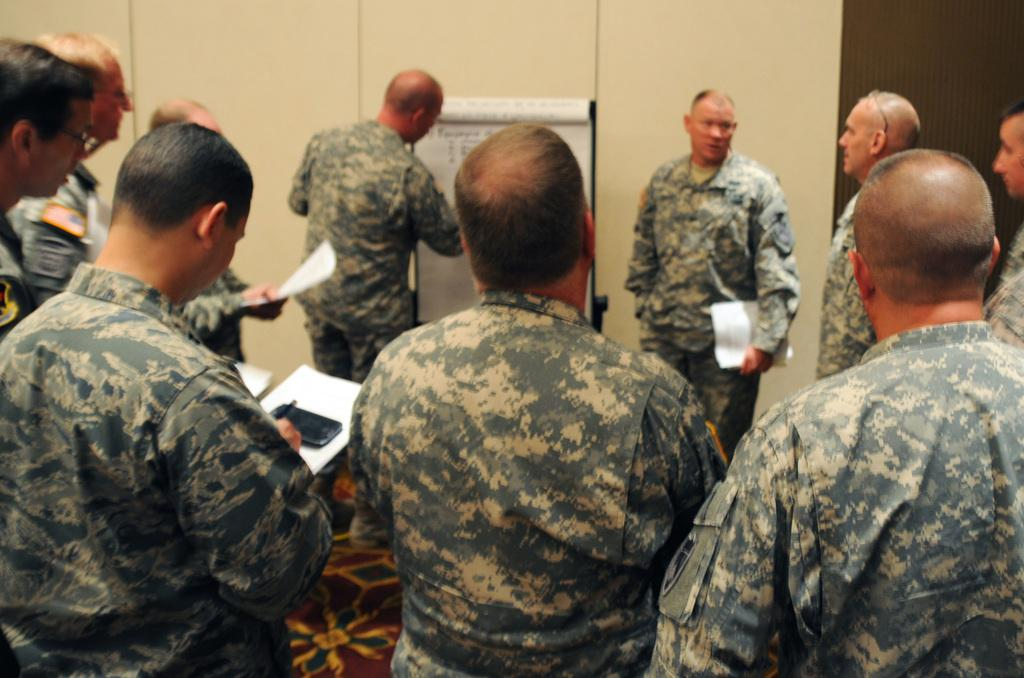What is happening in the image involving a group of people? In the image, there is a group of people holding papers in their hands. What are the people standing on? The people are standing on the floor. What can be seen in the background of the image? There is a wall in the background of the image. What type of machine is being used by the people to knit with yarn in the image? There is no machine or yarn present in the image; the people are holding papers in their hands. What color are the trousers worn by the people in the image? The provided facts do not mention the color or type of clothing worn by the people in the image. 